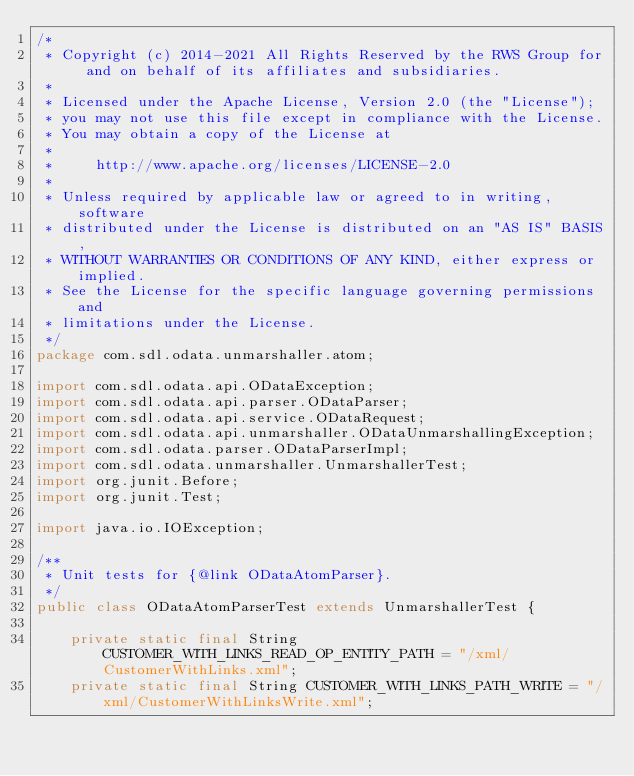Convert code to text. <code><loc_0><loc_0><loc_500><loc_500><_Java_>/*
 * Copyright (c) 2014-2021 All Rights Reserved by the RWS Group for and on behalf of its affiliates and subsidiaries.
 *
 * Licensed under the Apache License, Version 2.0 (the "License");
 * you may not use this file except in compliance with the License.
 * You may obtain a copy of the License at
 *
 *     http://www.apache.org/licenses/LICENSE-2.0
 *
 * Unless required by applicable law or agreed to in writing, software
 * distributed under the License is distributed on an "AS IS" BASIS,
 * WITHOUT WARRANTIES OR CONDITIONS OF ANY KIND, either express or implied.
 * See the License for the specific language governing permissions and
 * limitations under the License.
 */
package com.sdl.odata.unmarshaller.atom;

import com.sdl.odata.api.ODataException;
import com.sdl.odata.api.parser.ODataParser;
import com.sdl.odata.api.service.ODataRequest;
import com.sdl.odata.api.unmarshaller.ODataUnmarshallingException;
import com.sdl.odata.parser.ODataParserImpl;
import com.sdl.odata.unmarshaller.UnmarshallerTest;
import org.junit.Before;
import org.junit.Test;

import java.io.IOException;

/**
 * Unit tests for {@link ODataAtomParser}.
 */
public class ODataAtomParserTest extends UnmarshallerTest {

    private static final String CUSTOMER_WITH_LINKS_READ_OP_ENTITY_PATH = "/xml/CustomerWithLinks.xml";
    private static final String CUSTOMER_WITH_LINKS_PATH_WRITE = "/xml/CustomerWithLinksWrite.xml";
</code> 